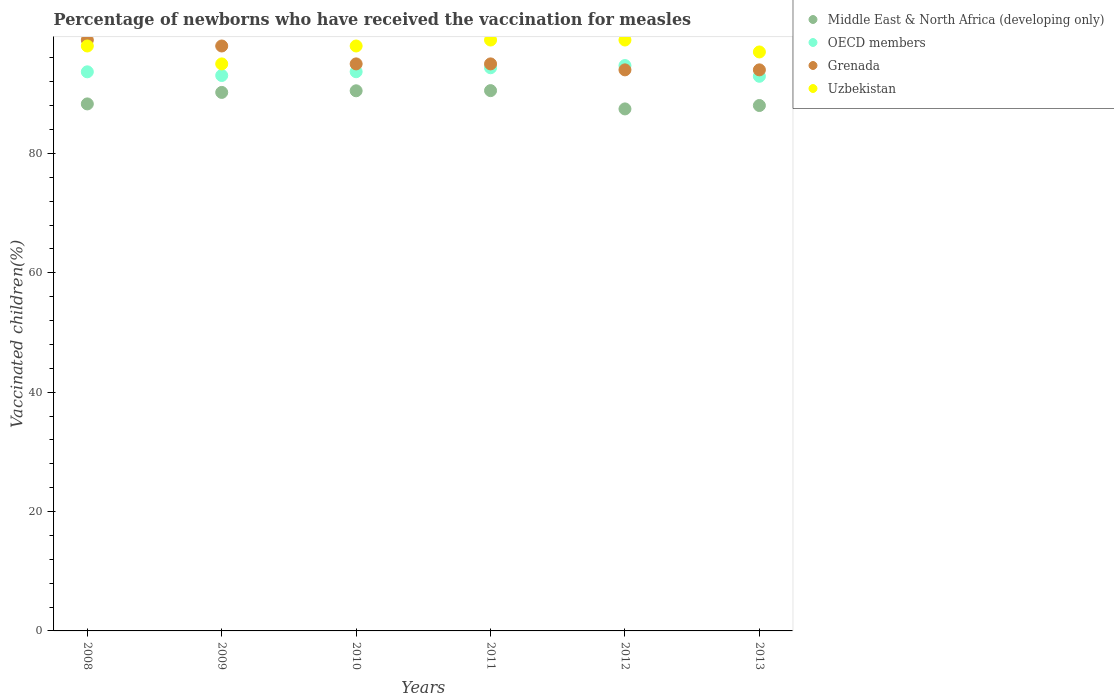What is the percentage of vaccinated children in OECD members in 2011?
Provide a succinct answer. 94.35. Across all years, what is the maximum percentage of vaccinated children in Uzbekistan?
Ensure brevity in your answer.  99. Across all years, what is the minimum percentage of vaccinated children in OECD members?
Provide a succinct answer. 92.92. What is the total percentage of vaccinated children in Middle East & North Africa (developing only) in the graph?
Your answer should be very brief. 535.01. What is the difference between the percentage of vaccinated children in OECD members in 2011 and that in 2012?
Keep it short and to the point. -0.37. What is the difference between the percentage of vaccinated children in Middle East & North Africa (developing only) in 2009 and the percentage of vaccinated children in Uzbekistan in 2012?
Provide a short and direct response. -8.78. What is the average percentage of vaccinated children in Middle East & North Africa (developing only) per year?
Your response must be concise. 89.17. In the year 2010, what is the difference between the percentage of vaccinated children in Middle East & North Africa (developing only) and percentage of vaccinated children in OECD members?
Your response must be concise. -3.2. In how many years, is the percentage of vaccinated children in OECD members greater than 64 %?
Give a very brief answer. 6. What is the ratio of the percentage of vaccinated children in Uzbekistan in 2009 to that in 2013?
Offer a very short reply. 0.98. Is the difference between the percentage of vaccinated children in Middle East & North Africa (developing only) in 2010 and 2011 greater than the difference between the percentage of vaccinated children in OECD members in 2010 and 2011?
Make the answer very short. Yes. What is the difference between the highest and the lowest percentage of vaccinated children in OECD members?
Your answer should be very brief. 1.8. In how many years, is the percentage of vaccinated children in Uzbekistan greater than the average percentage of vaccinated children in Uzbekistan taken over all years?
Offer a very short reply. 4. Is the sum of the percentage of vaccinated children in Uzbekistan in 2010 and 2012 greater than the maximum percentage of vaccinated children in OECD members across all years?
Make the answer very short. Yes. Is it the case that in every year, the sum of the percentage of vaccinated children in Middle East & North Africa (developing only) and percentage of vaccinated children in OECD members  is greater than the sum of percentage of vaccinated children in Grenada and percentage of vaccinated children in Uzbekistan?
Ensure brevity in your answer.  No. Is it the case that in every year, the sum of the percentage of vaccinated children in Grenada and percentage of vaccinated children in OECD members  is greater than the percentage of vaccinated children in Middle East & North Africa (developing only)?
Make the answer very short. Yes. Is the percentage of vaccinated children in Uzbekistan strictly less than the percentage of vaccinated children in Middle East & North Africa (developing only) over the years?
Ensure brevity in your answer.  No. What is the difference between two consecutive major ticks on the Y-axis?
Your response must be concise. 20. Are the values on the major ticks of Y-axis written in scientific E-notation?
Make the answer very short. No. Does the graph contain grids?
Your response must be concise. No. What is the title of the graph?
Your answer should be very brief. Percentage of newborns who have received the vaccination for measles. Does "Singapore" appear as one of the legend labels in the graph?
Provide a short and direct response. No. What is the label or title of the Y-axis?
Your response must be concise. Vaccinated children(%). What is the Vaccinated children(%) of Middle East & North Africa (developing only) in 2008?
Your answer should be compact. 88.29. What is the Vaccinated children(%) in OECD members in 2008?
Provide a short and direct response. 93.67. What is the Vaccinated children(%) of Grenada in 2008?
Provide a succinct answer. 99. What is the Vaccinated children(%) in Uzbekistan in 2008?
Keep it short and to the point. 98. What is the Vaccinated children(%) in Middle East & North Africa (developing only) in 2009?
Your response must be concise. 90.22. What is the Vaccinated children(%) in OECD members in 2009?
Provide a short and direct response. 93.06. What is the Vaccinated children(%) of Grenada in 2009?
Make the answer very short. 98. What is the Vaccinated children(%) of Middle East & North Africa (developing only) in 2010?
Your answer should be very brief. 90.49. What is the Vaccinated children(%) in OECD members in 2010?
Your answer should be very brief. 93.69. What is the Vaccinated children(%) in Grenada in 2010?
Offer a terse response. 95. What is the Vaccinated children(%) of Middle East & North Africa (developing only) in 2011?
Make the answer very short. 90.52. What is the Vaccinated children(%) of OECD members in 2011?
Provide a short and direct response. 94.35. What is the Vaccinated children(%) in Grenada in 2011?
Provide a short and direct response. 95. What is the Vaccinated children(%) in Uzbekistan in 2011?
Keep it short and to the point. 99. What is the Vaccinated children(%) of Middle East & North Africa (developing only) in 2012?
Your answer should be very brief. 87.46. What is the Vaccinated children(%) in OECD members in 2012?
Offer a terse response. 94.72. What is the Vaccinated children(%) of Grenada in 2012?
Your answer should be very brief. 94. What is the Vaccinated children(%) of Middle East & North Africa (developing only) in 2013?
Keep it short and to the point. 88.03. What is the Vaccinated children(%) in OECD members in 2013?
Keep it short and to the point. 92.92. What is the Vaccinated children(%) of Grenada in 2013?
Your answer should be very brief. 94. What is the Vaccinated children(%) of Uzbekistan in 2013?
Offer a very short reply. 97. Across all years, what is the maximum Vaccinated children(%) of Middle East & North Africa (developing only)?
Ensure brevity in your answer.  90.52. Across all years, what is the maximum Vaccinated children(%) of OECD members?
Your response must be concise. 94.72. Across all years, what is the maximum Vaccinated children(%) of Uzbekistan?
Keep it short and to the point. 99. Across all years, what is the minimum Vaccinated children(%) in Middle East & North Africa (developing only)?
Your answer should be compact. 87.46. Across all years, what is the minimum Vaccinated children(%) in OECD members?
Provide a short and direct response. 92.92. Across all years, what is the minimum Vaccinated children(%) of Grenada?
Offer a very short reply. 94. Across all years, what is the minimum Vaccinated children(%) in Uzbekistan?
Provide a short and direct response. 95. What is the total Vaccinated children(%) in Middle East & North Africa (developing only) in the graph?
Provide a succinct answer. 535.01. What is the total Vaccinated children(%) of OECD members in the graph?
Your answer should be compact. 562.41. What is the total Vaccinated children(%) of Grenada in the graph?
Ensure brevity in your answer.  575. What is the total Vaccinated children(%) in Uzbekistan in the graph?
Offer a terse response. 586. What is the difference between the Vaccinated children(%) of Middle East & North Africa (developing only) in 2008 and that in 2009?
Offer a very short reply. -1.93. What is the difference between the Vaccinated children(%) in OECD members in 2008 and that in 2009?
Your answer should be compact. 0.62. What is the difference between the Vaccinated children(%) of Middle East & North Africa (developing only) in 2008 and that in 2010?
Provide a succinct answer. -2.2. What is the difference between the Vaccinated children(%) in OECD members in 2008 and that in 2010?
Your answer should be compact. -0.02. What is the difference between the Vaccinated children(%) of Grenada in 2008 and that in 2010?
Make the answer very short. 4. What is the difference between the Vaccinated children(%) in Uzbekistan in 2008 and that in 2010?
Keep it short and to the point. 0. What is the difference between the Vaccinated children(%) in Middle East & North Africa (developing only) in 2008 and that in 2011?
Offer a very short reply. -2.23. What is the difference between the Vaccinated children(%) in OECD members in 2008 and that in 2011?
Ensure brevity in your answer.  -0.68. What is the difference between the Vaccinated children(%) of Grenada in 2008 and that in 2011?
Your response must be concise. 4. What is the difference between the Vaccinated children(%) of Uzbekistan in 2008 and that in 2011?
Give a very brief answer. -1. What is the difference between the Vaccinated children(%) of Middle East & North Africa (developing only) in 2008 and that in 2012?
Give a very brief answer. 0.84. What is the difference between the Vaccinated children(%) of OECD members in 2008 and that in 2012?
Make the answer very short. -1.05. What is the difference between the Vaccinated children(%) of Middle East & North Africa (developing only) in 2008 and that in 2013?
Your answer should be compact. 0.27. What is the difference between the Vaccinated children(%) in OECD members in 2008 and that in 2013?
Provide a succinct answer. 0.75. What is the difference between the Vaccinated children(%) in Uzbekistan in 2008 and that in 2013?
Offer a very short reply. 1. What is the difference between the Vaccinated children(%) in Middle East & North Africa (developing only) in 2009 and that in 2010?
Provide a short and direct response. -0.27. What is the difference between the Vaccinated children(%) of OECD members in 2009 and that in 2010?
Your answer should be compact. -0.63. What is the difference between the Vaccinated children(%) in Middle East & North Africa (developing only) in 2009 and that in 2011?
Give a very brief answer. -0.3. What is the difference between the Vaccinated children(%) of OECD members in 2009 and that in 2011?
Your answer should be very brief. -1.3. What is the difference between the Vaccinated children(%) of Uzbekistan in 2009 and that in 2011?
Offer a very short reply. -4. What is the difference between the Vaccinated children(%) in Middle East & North Africa (developing only) in 2009 and that in 2012?
Your response must be concise. 2.76. What is the difference between the Vaccinated children(%) of OECD members in 2009 and that in 2012?
Offer a very short reply. -1.67. What is the difference between the Vaccinated children(%) of Uzbekistan in 2009 and that in 2012?
Offer a terse response. -4. What is the difference between the Vaccinated children(%) of Middle East & North Africa (developing only) in 2009 and that in 2013?
Your response must be concise. 2.19. What is the difference between the Vaccinated children(%) in OECD members in 2009 and that in 2013?
Provide a short and direct response. 0.13. What is the difference between the Vaccinated children(%) of Middle East & North Africa (developing only) in 2010 and that in 2011?
Make the answer very short. -0.03. What is the difference between the Vaccinated children(%) of OECD members in 2010 and that in 2011?
Offer a terse response. -0.66. What is the difference between the Vaccinated children(%) in Grenada in 2010 and that in 2011?
Offer a terse response. 0. What is the difference between the Vaccinated children(%) in Middle East & North Africa (developing only) in 2010 and that in 2012?
Provide a succinct answer. 3.04. What is the difference between the Vaccinated children(%) of OECD members in 2010 and that in 2012?
Keep it short and to the point. -1.03. What is the difference between the Vaccinated children(%) of Uzbekistan in 2010 and that in 2012?
Your response must be concise. -1. What is the difference between the Vaccinated children(%) in Middle East & North Africa (developing only) in 2010 and that in 2013?
Offer a terse response. 2.46. What is the difference between the Vaccinated children(%) of OECD members in 2010 and that in 2013?
Your answer should be compact. 0.76. What is the difference between the Vaccinated children(%) in Uzbekistan in 2010 and that in 2013?
Give a very brief answer. 1. What is the difference between the Vaccinated children(%) of Middle East & North Africa (developing only) in 2011 and that in 2012?
Give a very brief answer. 3.06. What is the difference between the Vaccinated children(%) of OECD members in 2011 and that in 2012?
Provide a succinct answer. -0.37. What is the difference between the Vaccinated children(%) of Grenada in 2011 and that in 2012?
Offer a very short reply. 1. What is the difference between the Vaccinated children(%) in Middle East & North Africa (developing only) in 2011 and that in 2013?
Your response must be concise. 2.49. What is the difference between the Vaccinated children(%) of OECD members in 2011 and that in 2013?
Give a very brief answer. 1.43. What is the difference between the Vaccinated children(%) of Middle East & North Africa (developing only) in 2012 and that in 2013?
Keep it short and to the point. -0.57. What is the difference between the Vaccinated children(%) in OECD members in 2012 and that in 2013?
Your response must be concise. 1.8. What is the difference between the Vaccinated children(%) of Grenada in 2012 and that in 2013?
Your response must be concise. 0. What is the difference between the Vaccinated children(%) of Uzbekistan in 2012 and that in 2013?
Offer a very short reply. 2. What is the difference between the Vaccinated children(%) in Middle East & North Africa (developing only) in 2008 and the Vaccinated children(%) in OECD members in 2009?
Offer a terse response. -4.76. What is the difference between the Vaccinated children(%) of Middle East & North Africa (developing only) in 2008 and the Vaccinated children(%) of Grenada in 2009?
Provide a succinct answer. -9.71. What is the difference between the Vaccinated children(%) of Middle East & North Africa (developing only) in 2008 and the Vaccinated children(%) of Uzbekistan in 2009?
Make the answer very short. -6.71. What is the difference between the Vaccinated children(%) in OECD members in 2008 and the Vaccinated children(%) in Grenada in 2009?
Provide a succinct answer. -4.33. What is the difference between the Vaccinated children(%) of OECD members in 2008 and the Vaccinated children(%) of Uzbekistan in 2009?
Ensure brevity in your answer.  -1.33. What is the difference between the Vaccinated children(%) of Middle East & North Africa (developing only) in 2008 and the Vaccinated children(%) of OECD members in 2010?
Ensure brevity in your answer.  -5.39. What is the difference between the Vaccinated children(%) of Middle East & North Africa (developing only) in 2008 and the Vaccinated children(%) of Grenada in 2010?
Provide a succinct answer. -6.71. What is the difference between the Vaccinated children(%) of Middle East & North Africa (developing only) in 2008 and the Vaccinated children(%) of Uzbekistan in 2010?
Your answer should be very brief. -9.71. What is the difference between the Vaccinated children(%) in OECD members in 2008 and the Vaccinated children(%) in Grenada in 2010?
Your answer should be very brief. -1.33. What is the difference between the Vaccinated children(%) in OECD members in 2008 and the Vaccinated children(%) in Uzbekistan in 2010?
Offer a terse response. -4.33. What is the difference between the Vaccinated children(%) in Middle East & North Africa (developing only) in 2008 and the Vaccinated children(%) in OECD members in 2011?
Provide a succinct answer. -6.06. What is the difference between the Vaccinated children(%) of Middle East & North Africa (developing only) in 2008 and the Vaccinated children(%) of Grenada in 2011?
Keep it short and to the point. -6.71. What is the difference between the Vaccinated children(%) in Middle East & North Africa (developing only) in 2008 and the Vaccinated children(%) in Uzbekistan in 2011?
Offer a very short reply. -10.71. What is the difference between the Vaccinated children(%) in OECD members in 2008 and the Vaccinated children(%) in Grenada in 2011?
Offer a terse response. -1.33. What is the difference between the Vaccinated children(%) of OECD members in 2008 and the Vaccinated children(%) of Uzbekistan in 2011?
Your answer should be compact. -5.33. What is the difference between the Vaccinated children(%) in Grenada in 2008 and the Vaccinated children(%) in Uzbekistan in 2011?
Provide a succinct answer. 0. What is the difference between the Vaccinated children(%) in Middle East & North Africa (developing only) in 2008 and the Vaccinated children(%) in OECD members in 2012?
Ensure brevity in your answer.  -6.43. What is the difference between the Vaccinated children(%) of Middle East & North Africa (developing only) in 2008 and the Vaccinated children(%) of Grenada in 2012?
Ensure brevity in your answer.  -5.71. What is the difference between the Vaccinated children(%) of Middle East & North Africa (developing only) in 2008 and the Vaccinated children(%) of Uzbekistan in 2012?
Keep it short and to the point. -10.71. What is the difference between the Vaccinated children(%) of OECD members in 2008 and the Vaccinated children(%) of Grenada in 2012?
Your answer should be very brief. -0.33. What is the difference between the Vaccinated children(%) in OECD members in 2008 and the Vaccinated children(%) in Uzbekistan in 2012?
Your answer should be compact. -5.33. What is the difference between the Vaccinated children(%) of Middle East & North Africa (developing only) in 2008 and the Vaccinated children(%) of OECD members in 2013?
Your response must be concise. -4.63. What is the difference between the Vaccinated children(%) in Middle East & North Africa (developing only) in 2008 and the Vaccinated children(%) in Grenada in 2013?
Your answer should be compact. -5.71. What is the difference between the Vaccinated children(%) of Middle East & North Africa (developing only) in 2008 and the Vaccinated children(%) of Uzbekistan in 2013?
Provide a short and direct response. -8.71. What is the difference between the Vaccinated children(%) in OECD members in 2008 and the Vaccinated children(%) in Grenada in 2013?
Provide a succinct answer. -0.33. What is the difference between the Vaccinated children(%) in OECD members in 2008 and the Vaccinated children(%) in Uzbekistan in 2013?
Your response must be concise. -3.33. What is the difference between the Vaccinated children(%) of Middle East & North Africa (developing only) in 2009 and the Vaccinated children(%) of OECD members in 2010?
Ensure brevity in your answer.  -3.47. What is the difference between the Vaccinated children(%) in Middle East & North Africa (developing only) in 2009 and the Vaccinated children(%) in Grenada in 2010?
Offer a very short reply. -4.78. What is the difference between the Vaccinated children(%) of Middle East & North Africa (developing only) in 2009 and the Vaccinated children(%) of Uzbekistan in 2010?
Provide a succinct answer. -7.78. What is the difference between the Vaccinated children(%) in OECD members in 2009 and the Vaccinated children(%) in Grenada in 2010?
Offer a terse response. -1.94. What is the difference between the Vaccinated children(%) of OECD members in 2009 and the Vaccinated children(%) of Uzbekistan in 2010?
Make the answer very short. -4.94. What is the difference between the Vaccinated children(%) of Middle East & North Africa (developing only) in 2009 and the Vaccinated children(%) of OECD members in 2011?
Your answer should be very brief. -4.13. What is the difference between the Vaccinated children(%) in Middle East & North Africa (developing only) in 2009 and the Vaccinated children(%) in Grenada in 2011?
Give a very brief answer. -4.78. What is the difference between the Vaccinated children(%) in Middle East & North Africa (developing only) in 2009 and the Vaccinated children(%) in Uzbekistan in 2011?
Provide a succinct answer. -8.78. What is the difference between the Vaccinated children(%) of OECD members in 2009 and the Vaccinated children(%) of Grenada in 2011?
Provide a short and direct response. -1.94. What is the difference between the Vaccinated children(%) in OECD members in 2009 and the Vaccinated children(%) in Uzbekistan in 2011?
Offer a terse response. -5.94. What is the difference between the Vaccinated children(%) in Middle East & North Africa (developing only) in 2009 and the Vaccinated children(%) in OECD members in 2012?
Provide a short and direct response. -4.5. What is the difference between the Vaccinated children(%) in Middle East & North Africa (developing only) in 2009 and the Vaccinated children(%) in Grenada in 2012?
Offer a very short reply. -3.78. What is the difference between the Vaccinated children(%) of Middle East & North Africa (developing only) in 2009 and the Vaccinated children(%) of Uzbekistan in 2012?
Provide a short and direct response. -8.78. What is the difference between the Vaccinated children(%) of OECD members in 2009 and the Vaccinated children(%) of Grenada in 2012?
Offer a terse response. -0.94. What is the difference between the Vaccinated children(%) of OECD members in 2009 and the Vaccinated children(%) of Uzbekistan in 2012?
Ensure brevity in your answer.  -5.94. What is the difference between the Vaccinated children(%) of Middle East & North Africa (developing only) in 2009 and the Vaccinated children(%) of OECD members in 2013?
Keep it short and to the point. -2.7. What is the difference between the Vaccinated children(%) of Middle East & North Africa (developing only) in 2009 and the Vaccinated children(%) of Grenada in 2013?
Make the answer very short. -3.78. What is the difference between the Vaccinated children(%) of Middle East & North Africa (developing only) in 2009 and the Vaccinated children(%) of Uzbekistan in 2013?
Make the answer very short. -6.78. What is the difference between the Vaccinated children(%) in OECD members in 2009 and the Vaccinated children(%) in Grenada in 2013?
Your response must be concise. -0.94. What is the difference between the Vaccinated children(%) in OECD members in 2009 and the Vaccinated children(%) in Uzbekistan in 2013?
Your answer should be very brief. -3.94. What is the difference between the Vaccinated children(%) of Grenada in 2009 and the Vaccinated children(%) of Uzbekistan in 2013?
Give a very brief answer. 1. What is the difference between the Vaccinated children(%) in Middle East & North Africa (developing only) in 2010 and the Vaccinated children(%) in OECD members in 2011?
Your answer should be very brief. -3.86. What is the difference between the Vaccinated children(%) in Middle East & North Africa (developing only) in 2010 and the Vaccinated children(%) in Grenada in 2011?
Ensure brevity in your answer.  -4.51. What is the difference between the Vaccinated children(%) in Middle East & North Africa (developing only) in 2010 and the Vaccinated children(%) in Uzbekistan in 2011?
Give a very brief answer. -8.51. What is the difference between the Vaccinated children(%) in OECD members in 2010 and the Vaccinated children(%) in Grenada in 2011?
Provide a short and direct response. -1.31. What is the difference between the Vaccinated children(%) of OECD members in 2010 and the Vaccinated children(%) of Uzbekistan in 2011?
Ensure brevity in your answer.  -5.31. What is the difference between the Vaccinated children(%) of Grenada in 2010 and the Vaccinated children(%) of Uzbekistan in 2011?
Offer a very short reply. -4. What is the difference between the Vaccinated children(%) of Middle East & North Africa (developing only) in 2010 and the Vaccinated children(%) of OECD members in 2012?
Your answer should be compact. -4.23. What is the difference between the Vaccinated children(%) in Middle East & North Africa (developing only) in 2010 and the Vaccinated children(%) in Grenada in 2012?
Provide a short and direct response. -3.51. What is the difference between the Vaccinated children(%) in Middle East & North Africa (developing only) in 2010 and the Vaccinated children(%) in Uzbekistan in 2012?
Ensure brevity in your answer.  -8.51. What is the difference between the Vaccinated children(%) in OECD members in 2010 and the Vaccinated children(%) in Grenada in 2012?
Keep it short and to the point. -0.31. What is the difference between the Vaccinated children(%) of OECD members in 2010 and the Vaccinated children(%) of Uzbekistan in 2012?
Make the answer very short. -5.31. What is the difference between the Vaccinated children(%) of Middle East & North Africa (developing only) in 2010 and the Vaccinated children(%) of OECD members in 2013?
Provide a succinct answer. -2.43. What is the difference between the Vaccinated children(%) of Middle East & North Africa (developing only) in 2010 and the Vaccinated children(%) of Grenada in 2013?
Provide a succinct answer. -3.51. What is the difference between the Vaccinated children(%) in Middle East & North Africa (developing only) in 2010 and the Vaccinated children(%) in Uzbekistan in 2013?
Your answer should be very brief. -6.51. What is the difference between the Vaccinated children(%) of OECD members in 2010 and the Vaccinated children(%) of Grenada in 2013?
Give a very brief answer. -0.31. What is the difference between the Vaccinated children(%) in OECD members in 2010 and the Vaccinated children(%) in Uzbekistan in 2013?
Provide a succinct answer. -3.31. What is the difference between the Vaccinated children(%) of Middle East & North Africa (developing only) in 2011 and the Vaccinated children(%) of OECD members in 2012?
Make the answer very short. -4.2. What is the difference between the Vaccinated children(%) of Middle East & North Africa (developing only) in 2011 and the Vaccinated children(%) of Grenada in 2012?
Make the answer very short. -3.48. What is the difference between the Vaccinated children(%) in Middle East & North Africa (developing only) in 2011 and the Vaccinated children(%) in Uzbekistan in 2012?
Offer a very short reply. -8.48. What is the difference between the Vaccinated children(%) in OECD members in 2011 and the Vaccinated children(%) in Grenada in 2012?
Provide a succinct answer. 0.35. What is the difference between the Vaccinated children(%) in OECD members in 2011 and the Vaccinated children(%) in Uzbekistan in 2012?
Keep it short and to the point. -4.65. What is the difference between the Vaccinated children(%) of Grenada in 2011 and the Vaccinated children(%) of Uzbekistan in 2012?
Offer a terse response. -4. What is the difference between the Vaccinated children(%) in Middle East & North Africa (developing only) in 2011 and the Vaccinated children(%) in OECD members in 2013?
Your answer should be very brief. -2.4. What is the difference between the Vaccinated children(%) of Middle East & North Africa (developing only) in 2011 and the Vaccinated children(%) of Grenada in 2013?
Give a very brief answer. -3.48. What is the difference between the Vaccinated children(%) in Middle East & North Africa (developing only) in 2011 and the Vaccinated children(%) in Uzbekistan in 2013?
Ensure brevity in your answer.  -6.48. What is the difference between the Vaccinated children(%) in OECD members in 2011 and the Vaccinated children(%) in Grenada in 2013?
Keep it short and to the point. 0.35. What is the difference between the Vaccinated children(%) in OECD members in 2011 and the Vaccinated children(%) in Uzbekistan in 2013?
Keep it short and to the point. -2.65. What is the difference between the Vaccinated children(%) in Middle East & North Africa (developing only) in 2012 and the Vaccinated children(%) in OECD members in 2013?
Your answer should be compact. -5.47. What is the difference between the Vaccinated children(%) of Middle East & North Africa (developing only) in 2012 and the Vaccinated children(%) of Grenada in 2013?
Make the answer very short. -6.54. What is the difference between the Vaccinated children(%) of Middle East & North Africa (developing only) in 2012 and the Vaccinated children(%) of Uzbekistan in 2013?
Your response must be concise. -9.54. What is the difference between the Vaccinated children(%) in OECD members in 2012 and the Vaccinated children(%) in Grenada in 2013?
Ensure brevity in your answer.  0.72. What is the difference between the Vaccinated children(%) of OECD members in 2012 and the Vaccinated children(%) of Uzbekistan in 2013?
Your answer should be very brief. -2.28. What is the difference between the Vaccinated children(%) of Grenada in 2012 and the Vaccinated children(%) of Uzbekistan in 2013?
Your answer should be compact. -3. What is the average Vaccinated children(%) in Middle East & North Africa (developing only) per year?
Provide a short and direct response. 89.17. What is the average Vaccinated children(%) of OECD members per year?
Offer a very short reply. 93.74. What is the average Vaccinated children(%) of Grenada per year?
Provide a succinct answer. 95.83. What is the average Vaccinated children(%) of Uzbekistan per year?
Your answer should be very brief. 97.67. In the year 2008, what is the difference between the Vaccinated children(%) in Middle East & North Africa (developing only) and Vaccinated children(%) in OECD members?
Make the answer very short. -5.38. In the year 2008, what is the difference between the Vaccinated children(%) in Middle East & North Africa (developing only) and Vaccinated children(%) in Grenada?
Make the answer very short. -10.71. In the year 2008, what is the difference between the Vaccinated children(%) in Middle East & North Africa (developing only) and Vaccinated children(%) in Uzbekistan?
Your response must be concise. -9.71. In the year 2008, what is the difference between the Vaccinated children(%) of OECD members and Vaccinated children(%) of Grenada?
Your answer should be very brief. -5.33. In the year 2008, what is the difference between the Vaccinated children(%) of OECD members and Vaccinated children(%) of Uzbekistan?
Provide a succinct answer. -4.33. In the year 2008, what is the difference between the Vaccinated children(%) of Grenada and Vaccinated children(%) of Uzbekistan?
Offer a very short reply. 1. In the year 2009, what is the difference between the Vaccinated children(%) of Middle East & North Africa (developing only) and Vaccinated children(%) of OECD members?
Provide a short and direct response. -2.83. In the year 2009, what is the difference between the Vaccinated children(%) of Middle East & North Africa (developing only) and Vaccinated children(%) of Grenada?
Offer a very short reply. -7.78. In the year 2009, what is the difference between the Vaccinated children(%) in Middle East & North Africa (developing only) and Vaccinated children(%) in Uzbekistan?
Your answer should be compact. -4.78. In the year 2009, what is the difference between the Vaccinated children(%) of OECD members and Vaccinated children(%) of Grenada?
Make the answer very short. -4.94. In the year 2009, what is the difference between the Vaccinated children(%) in OECD members and Vaccinated children(%) in Uzbekistan?
Keep it short and to the point. -1.94. In the year 2010, what is the difference between the Vaccinated children(%) of Middle East & North Africa (developing only) and Vaccinated children(%) of OECD members?
Make the answer very short. -3.2. In the year 2010, what is the difference between the Vaccinated children(%) of Middle East & North Africa (developing only) and Vaccinated children(%) of Grenada?
Provide a short and direct response. -4.51. In the year 2010, what is the difference between the Vaccinated children(%) of Middle East & North Africa (developing only) and Vaccinated children(%) of Uzbekistan?
Offer a very short reply. -7.51. In the year 2010, what is the difference between the Vaccinated children(%) in OECD members and Vaccinated children(%) in Grenada?
Make the answer very short. -1.31. In the year 2010, what is the difference between the Vaccinated children(%) of OECD members and Vaccinated children(%) of Uzbekistan?
Your answer should be compact. -4.31. In the year 2011, what is the difference between the Vaccinated children(%) of Middle East & North Africa (developing only) and Vaccinated children(%) of OECD members?
Your answer should be compact. -3.83. In the year 2011, what is the difference between the Vaccinated children(%) in Middle East & North Africa (developing only) and Vaccinated children(%) in Grenada?
Provide a succinct answer. -4.48. In the year 2011, what is the difference between the Vaccinated children(%) of Middle East & North Africa (developing only) and Vaccinated children(%) of Uzbekistan?
Your answer should be very brief. -8.48. In the year 2011, what is the difference between the Vaccinated children(%) of OECD members and Vaccinated children(%) of Grenada?
Offer a terse response. -0.65. In the year 2011, what is the difference between the Vaccinated children(%) of OECD members and Vaccinated children(%) of Uzbekistan?
Give a very brief answer. -4.65. In the year 2011, what is the difference between the Vaccinated children(%) of Grenada and Vaccinated children(%) of Uzbekistan?
Your answer should be compact. -4. In the year 2012, what is the difference between the Vaccinated children(%) in Middle East & North Africa (developing only) and Vaccinated children(%) in OECD members?
Provide a short and direct response. -7.26. In the year 2012, what is the difference between the Vaccinated children(%) of Middle East & North Africa (developing only) and Vaccinated children(%) of Grenada?
Provide a short and direct response. -6.54. In the year 2012, what is the difference between the Vaccinated children(%) in Middle East & North Africa (developing only) and Vaccinated children(%) in Uzbekistan?
Provide a short and direct response. -11.54. In the year 2012, what is the difference between the Vaccinated children(%) in OECD members and Vaccinated children(%) in Grenada?
Your answer should be very brief. 0.72. In the year 2012, what is the difference between the Vaccinated children(%) in OECD members and Vaccinated children(%) in Uzbekistan?
Your answer should be very brief. -4.28. In the year 2013, what is the difference between the Vaccinated children(%) in Middle East & North Africa (developing only) and Vaccinated children(%) in OECD members?
Ensure brevity in your answer.  -4.9. In the year 2013, what is the difference between the Vaccinated children(%) of Middle East & North Africa (developing only) and Vaccinated children(%) of Grenada?
Keep it short and to the point. -5.97. In the year 2013, what is the difference between the Vaccinated children(%) in Middle East & North Africa (developing only) and Vaccinated children(%) in Uzbekistan?
Ensure brevity in your answer.  -8.97. In the year 2013, what is the difference between the Vaccinated children(%) of OECD members and Vaccinated children(%) of Grenada?
Provide a succinct answer. -1.08. In the year 2013, what is the difference between the Vaccinated children(%) in OECD members and Vaccinated children(%) in Uzbekistan?
Give a very brief answer. -4.08. In the year 2013, what is the difference between the Vaccinated children(%) of Grenada and Vaccinated children(%) of Uzbekistan?
Provide a succinct answer. -3. What is the ratio of the Vaccinated children(%) of Middle East & North Africa (developing only) in 2008 to that in 2009?
Provide a short and direct response. 0.98. What is the ratio of the Vaccinated children(%) in OECD members in 2008 to that in 2009?
Offer a very short reply. 1.01. What is the ratio of the Vaccinated children(%) in Grenada in 2008 to that in 2009?
Make the answer very short. 1.01. What is the ratio of the Vaccinated children(%) in Uzbekistan in 2008 to that in 2009?
Provide a short and direct response. 1.03. What is the ratio of the Vaccinated children(%) of Middle East & North Africa (developing only) in 2008 to that in 2010?
Keep it short and to the point. 0.98. What is the ratio of the Vaccinated children(%) of Grenada in 2008 to that in 2010?
Offer a very short reply. 1.04. What is the ratio of the Vaccinated children(%) in Uzbekistan in 2008 to that in 2010?
Give a very brief answer. 1. What is the ratio of the Vaccinated children(%) in Middle East & North Africa (developing only) in 2008 to that in 2011?
Keep it short and to the point. 0.98. What is the ratio of the Vaccinated children(%) in Grenada in 2008 to that in 2011?
Your answer should be compact. 1.04. What is the ratio of the Vaccinated children(%) in Middle East & North Africa (developing only) in 2008 to that in 2012?
Your response must be concise. 1.01. What is the ratio of the Vaccinated children(%) of OECD members in 2008 to that in 2012?
Provide a short and direct response. 0.99. What is the ratio of the Vaccinated children(%) in Grenada in 2008 to that in 2012?
Your answer should be very brief. 1.05. What is the ratio of the Vaccinated children(%) in Middle East & North Africa (developing only) in 2008 to that in 2013?
Your answer should be compact. 1. What is the ratio of the Vaccinated children(%) of Grenada in 2008 to that in 2013?
Offer a terse response. 1.05. What is the ratio of the Vaccinated children(%) in Uzbekistan in 2008 to that in 2013?
Ensure brevity in your answer.  1.01. What is the ratio of the Vaccinated children(%) of Middle East & North Africa (developing only) in 2009 to that in 2010?
Provide a succinct answer. 1. What is the ratio of the Vaccinated children(%) of Grenada in 2009 to that in 2010?
Ensure brevity in your answer.  1.03. What is the ratio of the Vaccinated children(%) in Uzbekistan in 2009 to that in 2010?
Provide a succinct answer. 0.97. What is the ratio of the Vaccinated children(%) in OECD members in 2009 to that in 2011?
Ensure brevity in your answer.  0.99. What is the ratio of the Vaccinated children(%) of Grenada in 2009 to that in 2011?
Provide a short and direct response. 1.03. What is the ratio of the Vaccinated children(%) of Uzbekistan in 2009 to that in 2011?
Your response must be concise. 0.96. What is the ratio of the Vaccinated children(%) of Middle East & North Africa (developing only) in 2009 to that in 2012?
Your response must be concise. 1.03. What is the ratio of the Vaccinated children(%) of OECD members in 2009 to that in 2012?
Provide a succinct answer. 0.98. What is the ratio of the Vaccinated children(%) of Grenada in 2009 to that in 2012?
Give a very brief answer. 1.04. What is the ratio of the Vaccinated children(%) in Uzbekistan in 2009 to that in 2012?
Make the answer very short. 0.96. What is the ratio of the Vaccinated children(%) in Middle East & North Africa (developing only) in 2009 to that in 2013?
Your answer should be compact. 1.02. What is the ratio of the Vaccinated children(%) in Grenada in 2009 to that in 2013?
Provide a succinct answer. 1.04. What is the ratio of the Vaccinated children(%) in Uzbekistan in 2009 to that in 2013?
Provide a short and direct response. 0.98. What is the ratio of the Vaccinated children(%) in Middle East & North Africa (developing only) in 2010 to that in 2011?
Offer a very short reply. 1. What is the ratio of the Vaccinated children(%) in Grenada in 2010 to that in 2011?
Your answer should be very brief. 1. What is the ratio of the Vaccinated children(%) of Uzbekistan in 2010 to that in 2011?
Your response must be concise. 0.99. What is the ratio of the Vaccinated children(%) in Middle East & North Africa (developing only) in 2010 to that in 2012?
Your answer should be very brief. 1.03. What is the ratio of the Vaccinated children(%) in Grenada in 2010 to that in 2012?
Give a very brief answer. 1.01. What is the ratio of the Vaccinated children(%) of Uzbekistan in 2010 to that in 2012?
Make the answer very short. 0.99. What is the ratio of the Vaccinated children(%) of Middle East & North Africa (developing only) in 2010 to that in 2013?
Your answer should be very brief. 1.03. What is the ratio of the Vaccinated children(%) in OECD members in 2010 to that in 2013?
Keep it short and to the point. 1.01. What is the ratio of the Vaccinated children(%) in Grenada in 2010 to that in 2013?
Give a very brief answer. 1.01. What is the ratio of the Vaccinated children(%) in Uzbekistan in 2010 to that in 2013?
Make the answer very short. 1.01. What is the ratio of the Vaccinated children(%) in Middle East & North Africa (developing only) in 2011 to that in 2012?
Provide a short and direct response. 1.03. What is the ratio of the Vaccinated children(%) in Grenada in 2011 to that in 2012?
Keep it short and to the point. 1.01. What is the ratio of the Vaccinated children(%) of Middle East & North Africa (developing only) in 2011 to that in 2013?
Your response must be concise. 1.03. What is the ratio of the Vaccinated children(%) in OECD members in 2011 to that in 2013?
Your answer should be very brief. 1.02. What is the ratio of the Vaccinated children(%) of Grenada in 2011 to that in 2013?
Ensure brevity in your answer.  1.01. What is the ratio of the Vaccinated children(%) in Uzbekistan in 2011 to that in 2013?
Give a very brief answer. 1.02. What is the ratio of the Vaccinated children(%) in Middle East & North Africa (developing only) in 2012 to that in 2013?
Offer a terse response. 0.99. What is the ratio of the Vaccinated children(%) in OECD members in 2012 to that in 2013?
Your response must be concise. 1.02. What is the ratio of the Vaccinated children(%) in Uzbekistan in 2012 to that in 2013?
Give a very brief answer. 1.02. What is the difference between the highest and the second highest Vaccinated children(%) of Middle East & North Africa (developing only)?
Your answer should be very brief. 0.03. What is the difference between the highest and the second highest Vaccinated children(%) of OECD members?
Your answer should be very brief. 0.37. What is the difference between the highest and the second highest Vaccinated children(%) in Uzbekistan?
Ensure brevity in your answer.  0. What is the difference between the highest and the lowest Vaccinated children(%) of Middle East & North Africa (developing only)?
Provide a succinct answer. 3.06. What is the difference between the highest and the lowest Vaccinated children(%) in OECD members?
Ensure brevity in your answer.  1.8. 